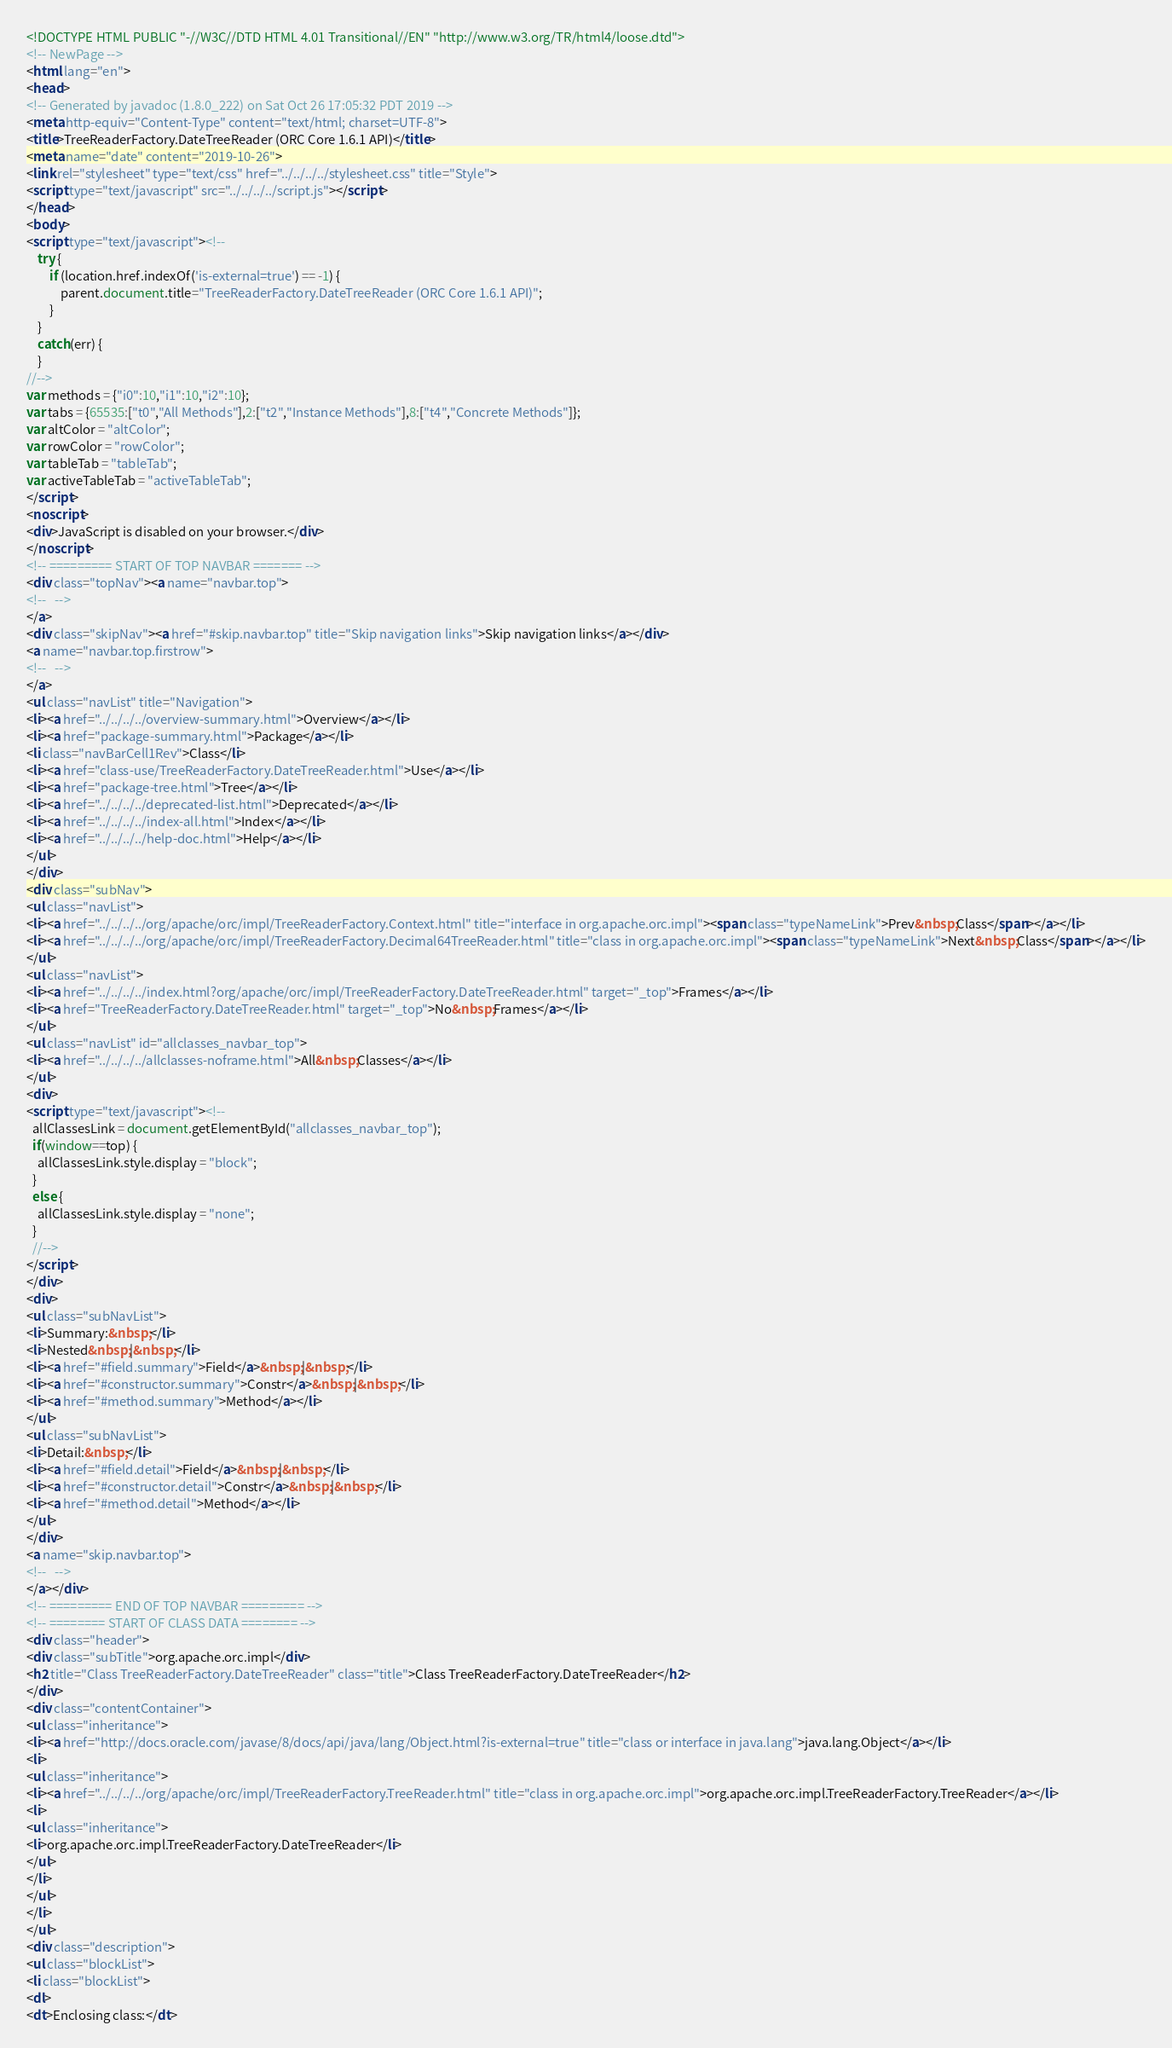<code> <loc_0><loc_0><loc_500><loc_500><_HTML_><!DOCTYPE HTML PUBLIC "-//W3C//DTD HTML 4.01 Transitional//EN" "http://www.w3.org/TR/html4/loose.dtd">
<!-- NewPage -->
<html lang="en">
<head>
<!-- Generated by javadoc (1.8.0_222) on Sat Oct 26 17:05:32 PDT 2019 -->
<meta http-equiv="Content-Type" content="text/html; charset=UTF-8">
<title>TreeReaderFactory.DateTreeReader (ORC Core 1.6.1 API)</title>
<meta name="date" content="2019-10-26">
<link rel="stylesheet" type="text/css" href="../../../../stylesheet.css" title="Style">
<script type="text/javascript" src="../../../../script.js"></script>
</head>
<body>
<script type="text/javascript"><!--
    try {
        if (location.href.indexOf('is-external=true') == -1) {
            parent.document.title="TreeReaderFactory.DateTreeReader (ORC Core 1.6.1 API)";
        }
    }
    catch(err) {
    }
//-->
var methods = {"i0":10,"i1":10,"i2":10};
var tabs = {65535:["t0","All Methods"],2:["t2","Instance Methods"],8:["t4","Concrete Methods"]};
var altColor = "altColor";
var rowColor = "rowColor";
var tableTab = "tableTab";
var activeTableTab = "activeTableTab";
</script>
<noscript>
<div>JavaScript is disabled on your browser.</div>
</noscript>
<!-- ========= START OF TOP NAVBAR ======= -->
<div class="topNav"><a name="navbar.top">
<!--   -->
</a>
<div class="skipNav"><a href="#skip.navbar.top" title="Skip navigation links">Skip navigation links</a></div>
<a name="navbar.top.firstrow">
<!--   -->
</a>
<ul class="navList" title="Navigation">
<li><a href="../../../../overview-summary.html">Overview</a></li>
<li><a href="package-summary.html">Package</a></li>
<li class="navBarCell1Rev">Class</li>
<li><a href="class-use/TreeReaderFactory.DateTreeReader.html">Use</a></li>
<li><a href="package-tree.html">Tree</a></li>
<li><a href="../../../../deprecated-list.html">Deprecated</a></li>
<li><a href="../../../../index-all.html">Index</a></li>
<li><a href="../../../../help-doc.html">Help</a></li>
</ul>
</div>
<div class="subNav">
<ul class="navList">
<li><a href="../../../../org/apache/orc/impl/TreeReaderFactory.Context.html" title="interface in org.apache.orc.impl"><span class="typeNameLink">Prev&nbsp;Class</span></a></li>
<li><a href="../../../../org/apache/orc/impl/TreeReaderFactory.Decimal64TreeReader.html" title="class in org.apache.orc.impl"><span class="typeNameLink">Next&nbsp;Class</span></a></li>
</ul>
<ul class="navList">
<li><a href="../../../../index.html?org/apache/orc/impl/TreeReaderFactory.DateTreeReader.html" target="_top">Frames</a></li>
<li><a href="TreeReaderFactory.DateTreeReader.html" target="_top">No&nbsp;Frames</a></li>
</ul>
<ul class="navList" id="allclasses_navbar_top">
<li><a href="../../../../allclasses-noframe.html">All&nbsp;Classes</a></li>
</ul>
<div>
<script type="text/javascript"><!--
  allClassesLink = document.getElementById("allclasses_navbar_top");
  if(window==top) {
    allClassesLink.style.display = "block";
  }
  else {
    allClassesLink.style.display = "none";
  }
  //-->
</script>
</div>
<div>
<ul class="subNavList">
<li>Summary:&nbsp;</li>
<li>Nested&nbsp;|&nbsp;</li>
<li><a href="#field.summary">Field</a>&nbsp;|&nbsp;</li>
<li><a href="#constructor.summary">Constr</a>&nbsp;|&nbsp;</li>
<li><a href="#method.summary">Method</a></li>
</ul>
<ul class="subNavList">
<li>Detail:&nbsp;</li>
<li><a href="#field.detail">Field</a>&nbsp;|&nbsp;</li>
<li><a href="#constructor.detail">Constr</a>&nbsp;|&nbsp;</li>
<li><a href="#method.detail">Method</a></li>
</ul>
</div>
<a name="skip.navbar.top">
<!--   -->
</a></div>
<!-- ========= END OF TOP NAVBAR ========= -->
<!-- ======== START OF CLASS DATA ======== -->
<div class="header">
<div class="subTitle">org.apache.orc.impl</div>
<h2 title="Class TreeReaderFactory.DateTreeReader" class="title">Class TreeReaderFactory.DateTreeReader</h2>
</div>
<div class="contentContainer">
<ul class="inheritance">
<li><a href="http://docs.oracle.com/javase/8/docs/api/java/lang/Object.html?is-external=true" title="class or interface in java.lang">java.lang.Object</a></li>
<li>
<ul class="inheritance">
<li><a href="../../../../org/apache/orc/impl/TreeReaderFactory.TreeReader.html" title="class in org.apache.orc.impl">org.apache.orc.impl.TreeReaderFactory.TreeReader</a></li>
<li>
<ul class="inheritance">
<li>org.apache.orc.impl.TreeReaderFactory.DateTreeReader</li>
</ul>
</li>
</ul>
</li>
</ul>
<div class="description">
<ul class="blockList">
<li class="blockList">
<dl>
<dt>Enclosing class:</dt></code> 